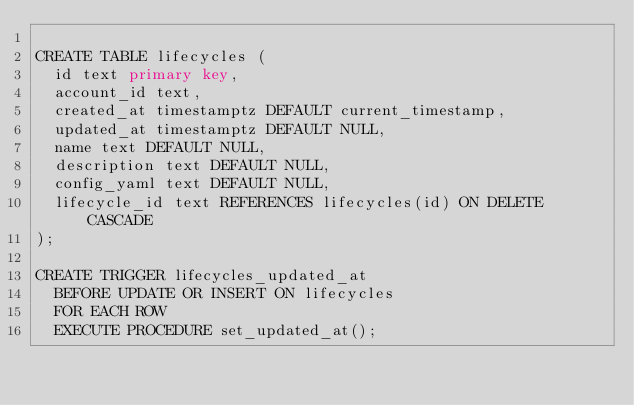Convert code to text. <code><loc_0><loc_0><loc_500><loc_500><_SQL_>
CREATE TABLE lifecycles (
  id text primary key,
  account_id text,
  created_at timestamptz DEFAULT current_timestamp,
  updated_at timestamptz DEFAULT NULL,
  name text DEFAULT NULL,
  description text DEFAULT NULL,
  config_yaml text DEFAULT NULL,
  lifecycle_id text REFERENCES lifecycles(id) ON DELETE CASCADE
);

CREATE TRIGGER lifecycles_updated_at
  BEFORE UPDATE OR INSERT ON lifecycles
  FOR EACH ROW
  EXECUTE PROCEDURE set_updated_at();

</code> 